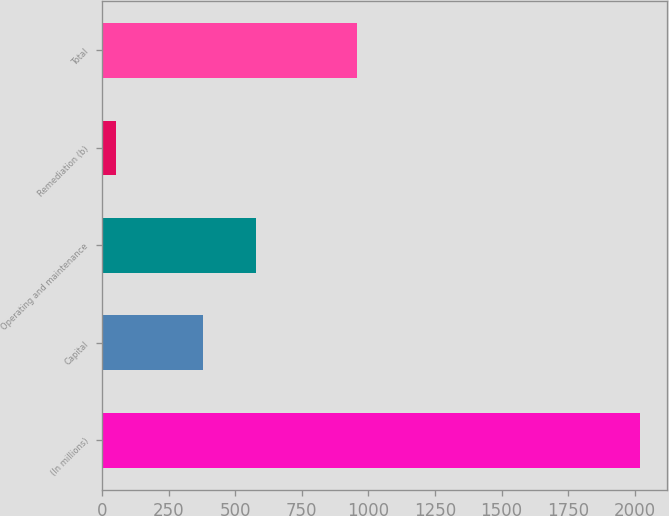<chart> <loc_0><loc_0><loc_500><loc_500><bar_chart><fcel>(In millions)<fcel>Capital<fcel>Operating and maintenance<fcel>Remediation (b)<fcel>Total<nl><fcel>2018<fcel>380<fcel>576.6<fcel>52<fcel>957<nl></chart> 